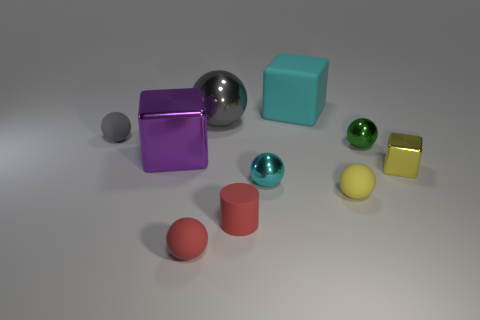Subtract 1 spheres. How many spheres are left? 5 Subtract all yellow balls. How many balls are left? 5 Subtract all small yellow spheres. How many spheres are left? 5 Subtract all red spheres. Subtract all yellow cylinders. How many spheres are left? 5 Subtract all cubes. How many objects are left? 7 Add 6 tiny yellow matte things. How many tiny yellow matte things are left? 7 Add 3 tiny cyan things. How many tiny cyan things exist? 4 Subtract 0 brown cylinders. How many objects are left? 10 Subtract all big cyan cubes. Subtract all cyan shiny balls. How many objects are left? 8 